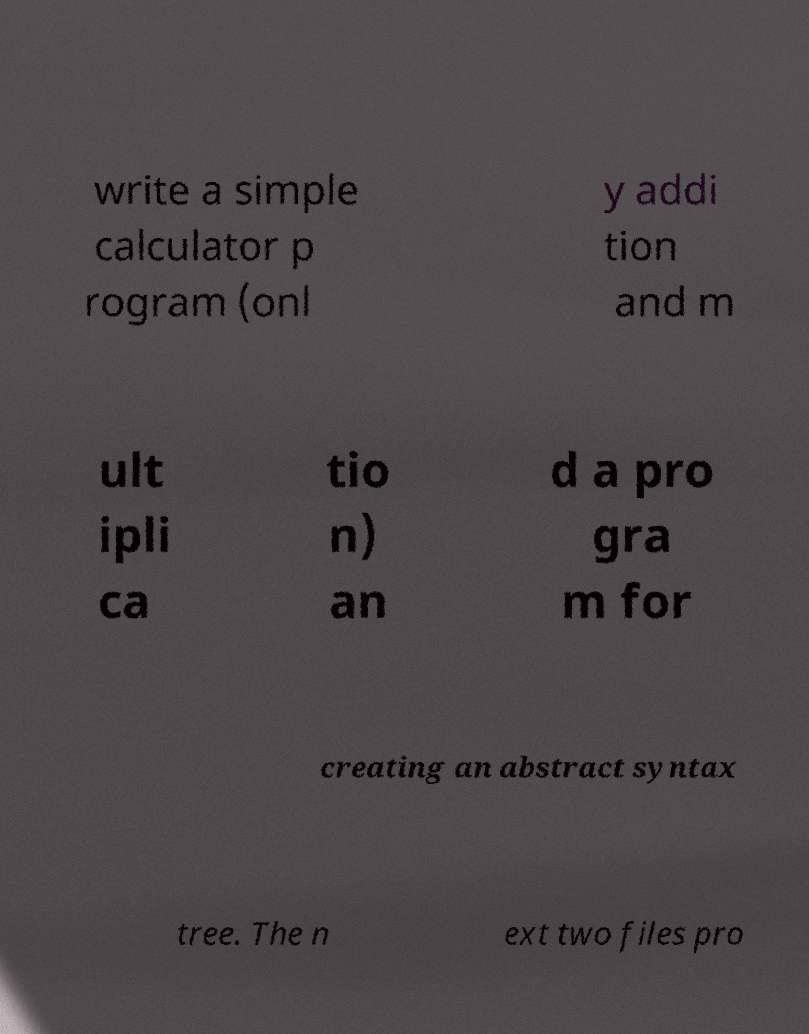What messages or text are displayed in this image? I need them in a readable, typed format. write a simple calculator p rogram (onl y addi tion and m ult ipli ca tio n) an d a pro gra m for creating an abstract syntax tree. The n ext two files pro 